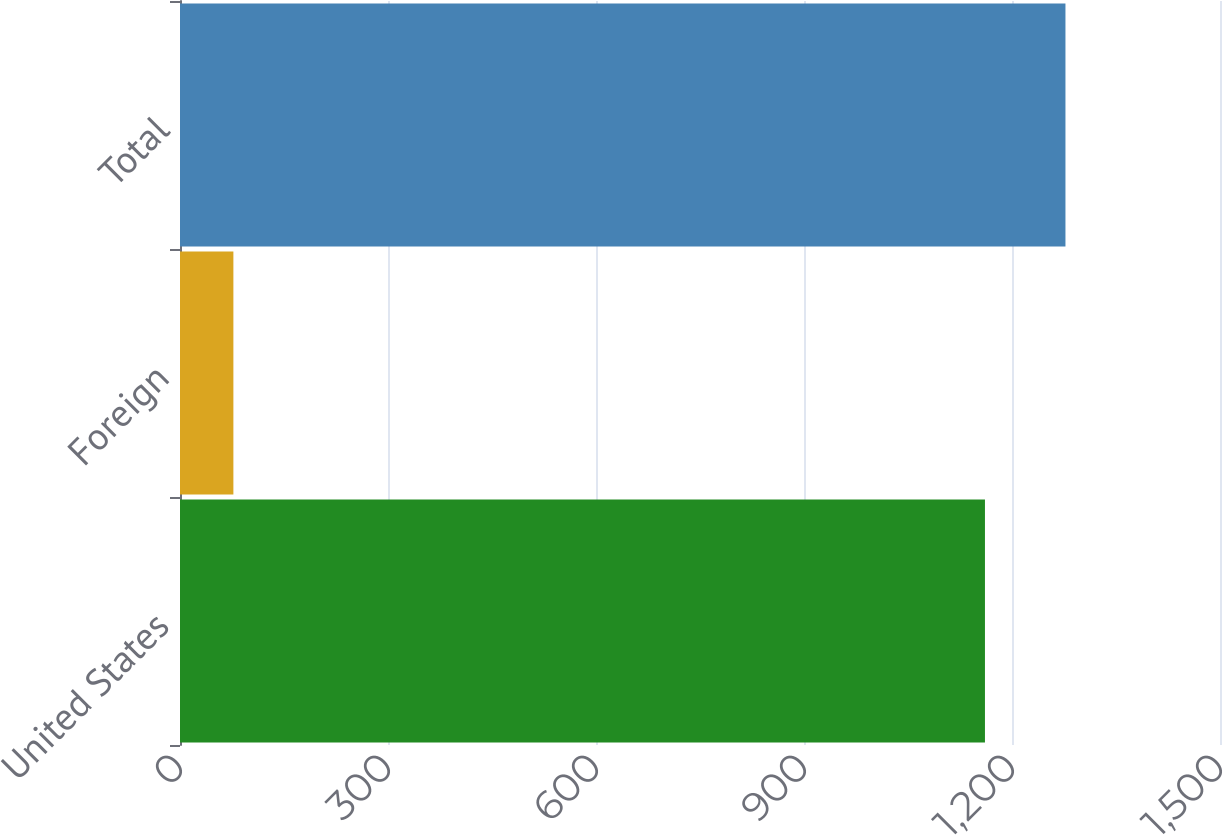Convert chart to OTSL. <chart><loc_0><loc_0><loc_500><loc_500><bar_chart><fcel>United States<fcel>Foreign<fcel>Total<nl><fcel>1161<fcel>77<fcel>1277.1<nl></chart> 